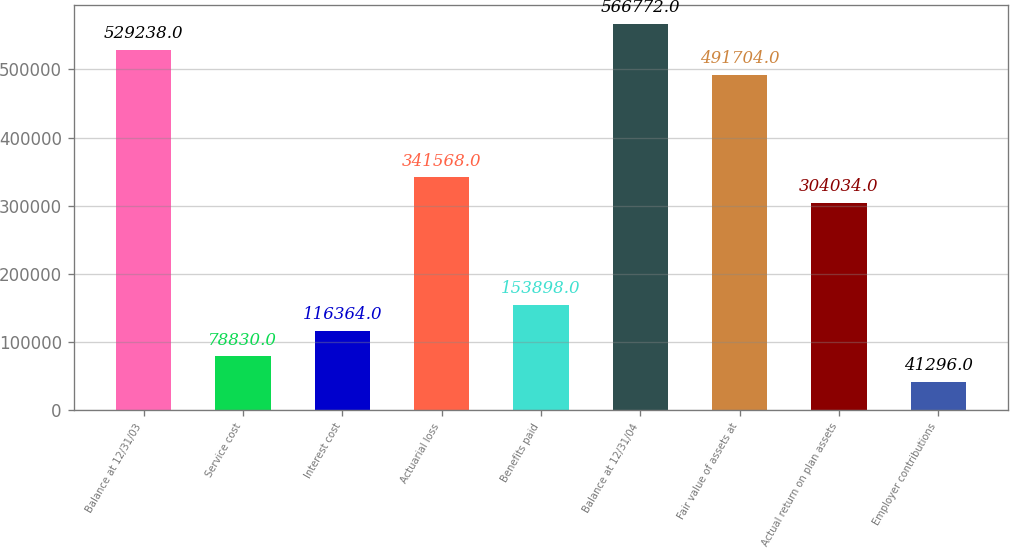<chart> <loc_0><loc_0><loc_500><loc_500><bar_chart><fcel>Balance at 12/31/03<fcel>Service cost<fcel>Interest cost<fcel>Actuarial loss<fcel>Benefits paid<fcel>Balance at 12/31/04<fcel>Fair value of assets at<fcel>Actual return on plan assets<fcel>Employer contributions<nl><fcel>529238<fcel>78830<fcel>116364<fcel>341568<fcel>153898<fcel>566772<fcel>491704<fcel>304034<fcel>41296<nl></chart> 